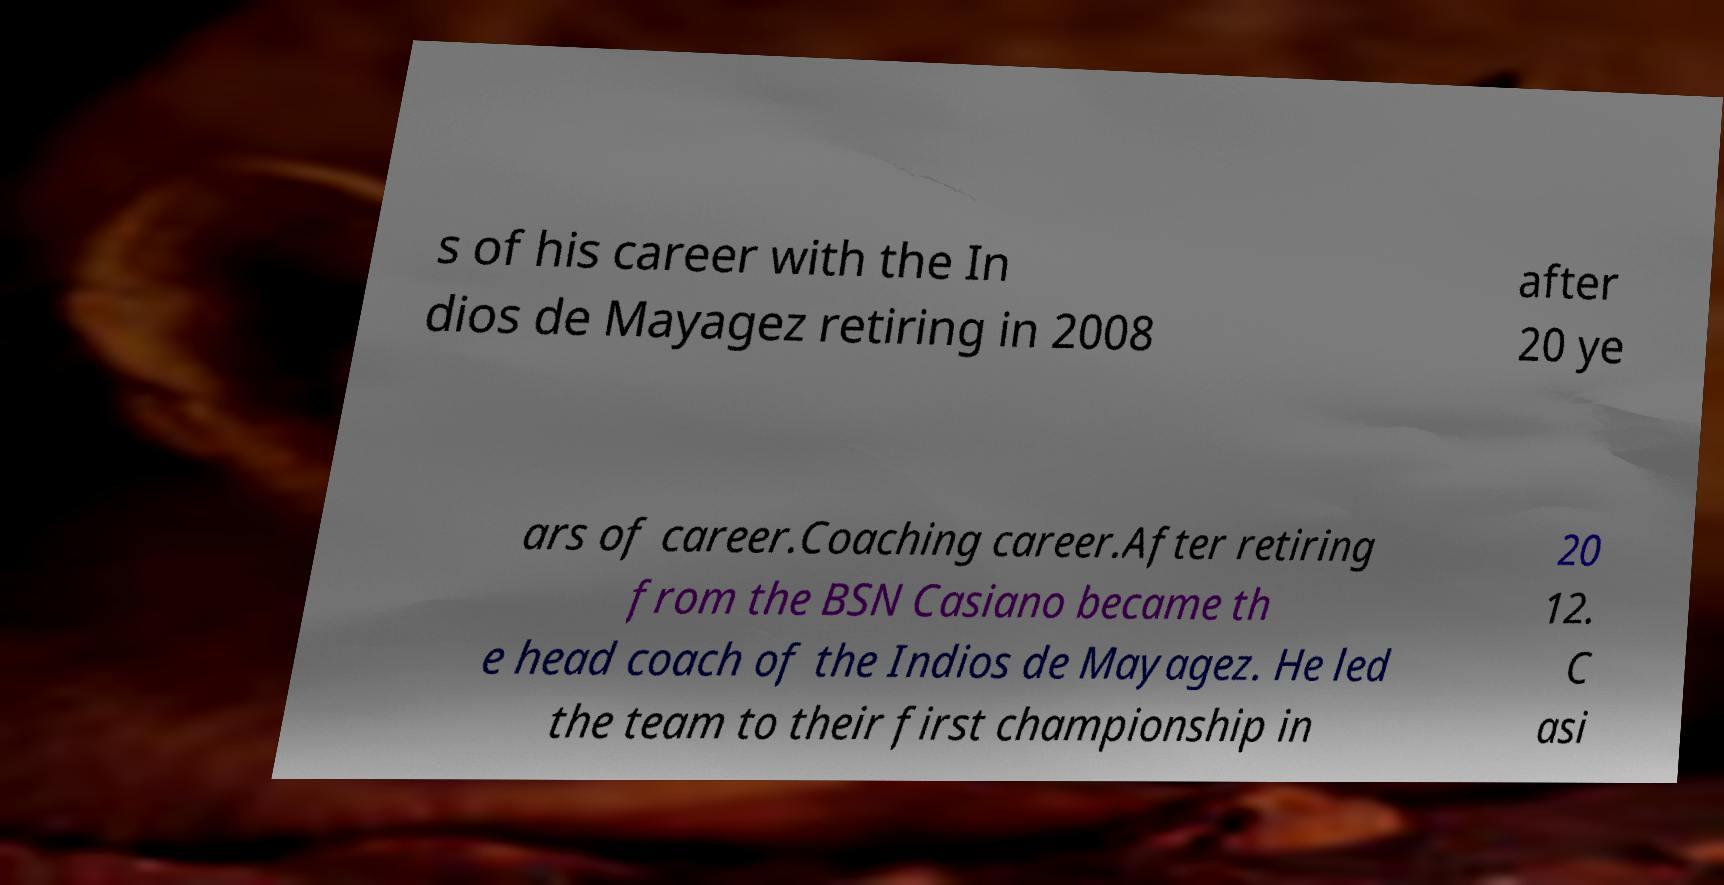Can you accurately transcribe the text from the provided image for me? s of his career with the In dios de Mayagez retiring in 2008 after 20 ye ars of career.Coaching career.After retiring from the BSN Casiano became th e head coach of the Indios de Mayagez. He led the team to their first championship in 20 12. C asi 